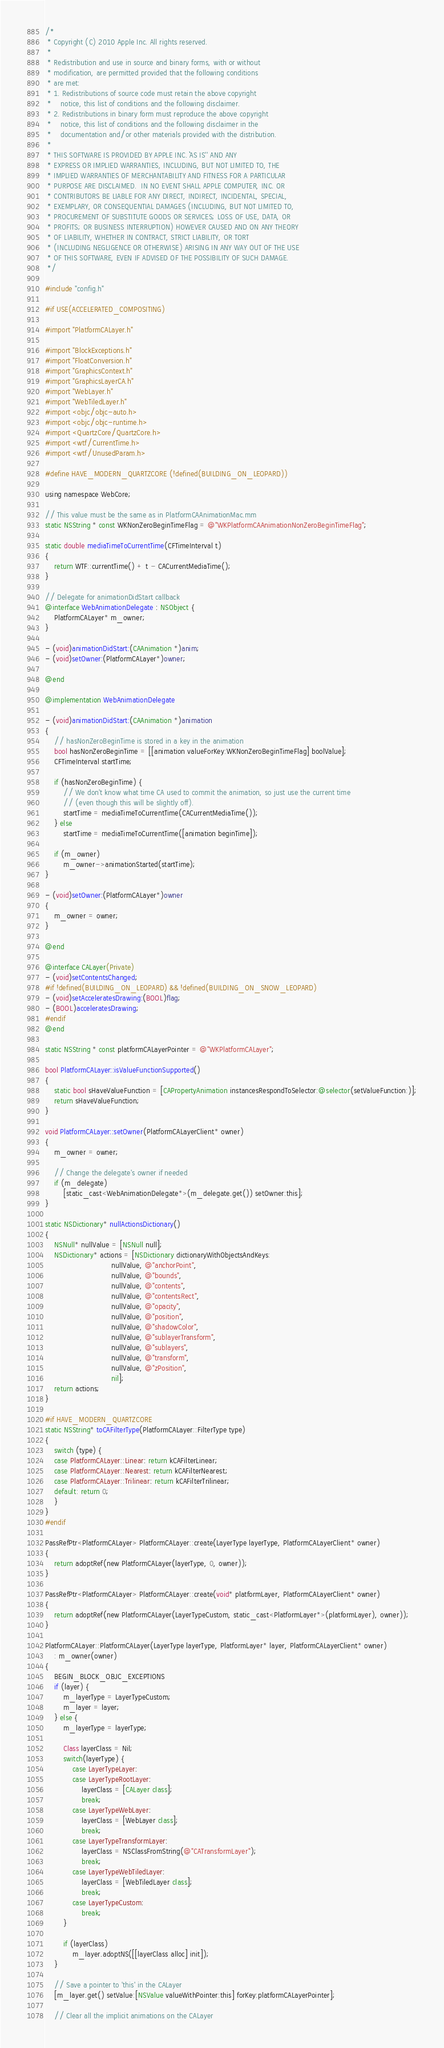<code> <loc_0><loc_0><loc_500><loc_500><_ObjectiveC_>/*
 * Copyright (C) 2010 Apple Inc. All rights reserved.
 *
 * Redistribution and use in source and binary forms, with or without
 * modification, are permitted provided that the following conditions
 * are met:
 * 1. Redistributions of source code must retain the above copyright
 *    notice, this list of conditions and the following disclaimer.
 * 2. Redistributions in binary form must reproduce the above copyright
 *    notice, this list of conditions and the following disclaimer in the
 *    documentation and/or other materials provided with the distribution.
 *
 * THIS SOFTWARE IS PROVIDED BY APPLE INC. ``AS IS'' AND ANY
 * EXPRESS OR IMPLIED WARRANTIES, INCLUDING, BUT NOT LIMITED TO, THE
 * IMPLIED WARRANTIES OF MERCHANTABILITY AND FITNESS FOR A PARTICULAR
 * PURPOSE ARE DISCLAIMED.  IN NO EVENT SHALL APPLE COMPUTER, INC. OR
 * CONTRIBUTORS BE LIABLE FOR ANY DIRECT, INDIRECT, INCIDENTAL, SPECIAL,
 * EXEMPLARY, OR CONSEQUENTIAL DAMAGES (INCLUDING, BUT NOT LIMITED TO,
 * PROCUREMENT OF SUBSTITUTE GOODS OR SERVICES; LOSS OF USE, DATA, OR
 * PROFITS; OR BUSINESS INTERRUPTION) HOWEVER CAUSED AND ON ANY THEORY
 * OF LIABILITY, WHETHER IN CONTRACT, STRICT LIABILITY, OR TORT
 * (INCLUDING NEGLIGENCE OR OTHERWISE) ARISING IN ANY WAY OUT OF THE USE
 * OF THIS SOFTWARE, EVEN IF ADVISED OF THE POSSIBILITY OF SUCH DAMAGE. 
 */

#include "config.h"

#if USE(ACCELERATED_COMPOSITING)

#import "PlatformCALayer.h"

#import "BlockExceptions.h"
#import "FloatConversion.h"
#import "GraphicsContext.h"
#import "GraphicsLayerCA.h"
#import "WebLayer.h"
#import "WebTiledLayer.h"
#import <objc/objc-auto.h>
#import <objc/objc-runtime.h>
#import <QuartzCore/QuartzCore.h>
#import <wtf/CurrentTime.h>
#import <wtf/UnusedParam.h>

#define HAVE_MODERN_QUARTZCORE (!defined(BUILDING_ON_LEOPARD))

using namespace WebCore;

// This value must be the same as in PlatformCAAnimationMac.mm
static NSString * const WKNonZeroBeginTimeFlag = @"WKPlatformCAAnimationNonZeroBeginTimeFlag";

static double mediaTimeToCurrentTime(CFTimeInterval t)
{
    return WTF::currentTime() + t - CACurrentMediaTime();
}

// Delegate for animationDidStart callback
@interface WebAnimationDelegate : NSObject {
    PlatformCALayer* m_owner;
}

- (void)animationDidStart:(CAAnimation *)anim;
- (void)setOwner:(PlatformCALayer*)owner;

@end

@implementation WebAnimationDelegate

- (void)animationDidStart:(CAAnimation *)animation
{
    // hasNonZeroBeginTime is stored in a key in the animation
    bool hasNonZeroBeginTime = [[animation valueForKey:WKNonZeroBeginTimeFlag] boolValue];
    CFTimeInterval startTime;
    
    if (hasNonZeroBeginTime) {
        // We don't know what time CA used to commit the animation, so just use the current time
        // (even though this will be slightly off).
        startTime = mediaTimeToCurrentTime(CACurrentMediaTime());
    } else
        startTime = mediaTimeToCurrentTime([animation beginTime]);

    if (m_owner)
        m_owner->animationStarted(startTime);
}

- (void)setOwner:(PlatformCALayer*)owner
{
    m_owner = owner;
}

@end

@interface CALayer(Private)
- (void)setContentsChanged;
#if !defined(BUILDING_ON_LEOPARD) && !defined(BUILDING_ON_SNOW_LEOPARD)
- (void)setAcceleratesDrawing:(BOOL)flag;
- (BOOL)acceleratesDrawing;
#endif
@end

static NSString * const platformCALayerPointer = @"WKPlatformCALayer";

bool PlatformCALayer::isValueFunctionSupported()
{
    static bool sHaveValueFunction = [CAPropertyAnimation instancesRespondToSelector:@selector(setValueFunction:)];
    return sHaveValueFunction;
}

void PlatformCALayer::setOwner(PlatformCALayerClient* owner)
{
    m_owner = owner;
    
    // Change the delegate's owner if needed
    if (m_delegate)
        [static_cast<WebAnimationDelegate*>(m_delegate.get()) setOwner:this];        
}

static NSDictionary* nullActionsDictionary()
{
    NSNull* nullValue = [NSNull null];
    NSDictionary* actions = [NSDictionary dictionaryWithObjectsAndKeys:
                             nullValue, @"anchorPoint",
                             nullValue, @"bounds",
                             nullValue, @"contents",
                             nullValue, @"contentsRect",
                             nullValue, @"opacity",
                             nullValue, @"position",
                             nullValue, @"shadowColor",
                             nullValue, @"sublayerTransform",
                             nullValue, @"sublayers",
                             nullValue, @"transform",
                             nullValue, @"zPosition",
                             nil];
    return actions;
}

#if HAVE_MODERN_QUARTZCORE
static NSString* toCAFilterType(PlatformCALayer::FilterType type)
{
    switch (type) {
    case PlatformCALayer::Linear: return kCAFilterLinear;
    case PlatformCALayer::Nearest: return kCAFilterNearest;
    case PlatformCALayer::Trilinear: return kCAFilterTrilinear;
    default: return 0;
    }
}
#endif

PassRefPtr<PlatformCALayer> PlatformCALayer::create(LayerType layerType, PlatformCALayerClient* owner)
{
    return adoptRef(new PlatformCALayer(layerType, 0, owner));
}

PassRefPtr<PlatformCALayer> PlatformCALayer::create(void* platformLayer, PlatformCALayerClient* owner)
{
    return adoptRef(new PlatformCALayer(LayerTypeCustom, static_cast<PlatformLayer*>(platformLayer), owner));
}

PlatformCALayer::PlatformCALayer(LayerType layerType, PlatformLayer* layer, PlatformCALayerClient* owner)
    : m_owner(owner)
{
    BEGIN_BLOCK_OBJC_EXCEPTIONS
    if (layer) {
        m_layerType = LayerTypeCustom;
        m_layer = layer;
    } else {
        m_layerType = layerType;
    
        Class layerClass = Nil;
        switch(layerType) {
            case LayerTypeLayer:
            case LayerTypeRootLayer:
                layerClass = [CALayer class];
                break;
            case LayerTypeWebLayer:
                layerClass = [WebLayer class];
                break;
            case LayerTypeTransformLayer:
                layerClass = NSClassFromString(@"CATransformLayer");
                break;
            case LayerTypeWebTiledLayer:
                layerClass = [WebTiledLayer class];
                break;
            case LayerTypeCustom:
                break;
        }

        if (layerClass)
            m_layer.adoptNS([[layerClass alloc] init]);
    }
    
    // Save a pointer to 'this' in the CALayer
    [m_layer.get() setValue:[NSValue valueWithPointer:this] forKey:platformCALayerPointer];
    
    // Clear all the implicit animations on the CALayer</code> 